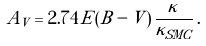Convert formula to latex. <formula><loc_0><loc_0><loc_500><loc_500>A _ { V } = 2 . 7 4 \, E ( B - V ) \, \frac { \kappa } { \kappa _ { S M C } } \, .</formula> 